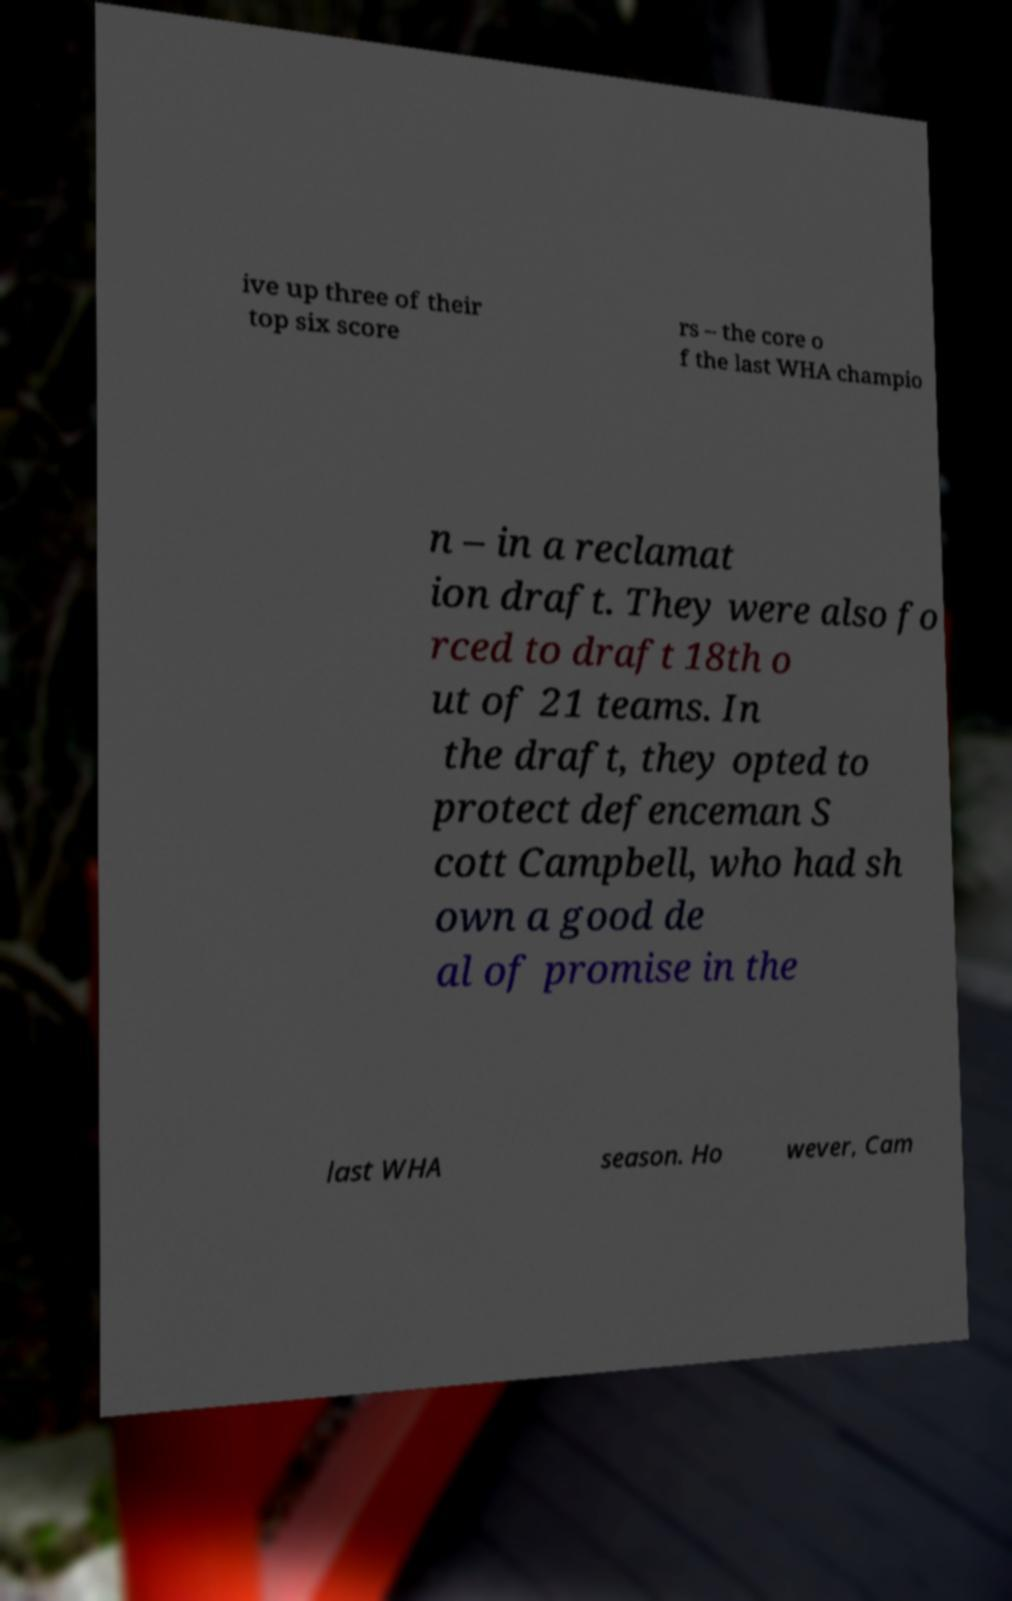There's text embedded in this image that I need extracted. Can you transcribe it verbatim? ive up three of their top six score rs – the core o f the last WHA champio n – in a reclamat ion draft. They were also fo rced to draft 18th o ut of 21 teams. In the draft, they opted to protect defenceman S cott Campbell, who had sh own a good de al of promise in the last WHA season. Ho wever, Cam 